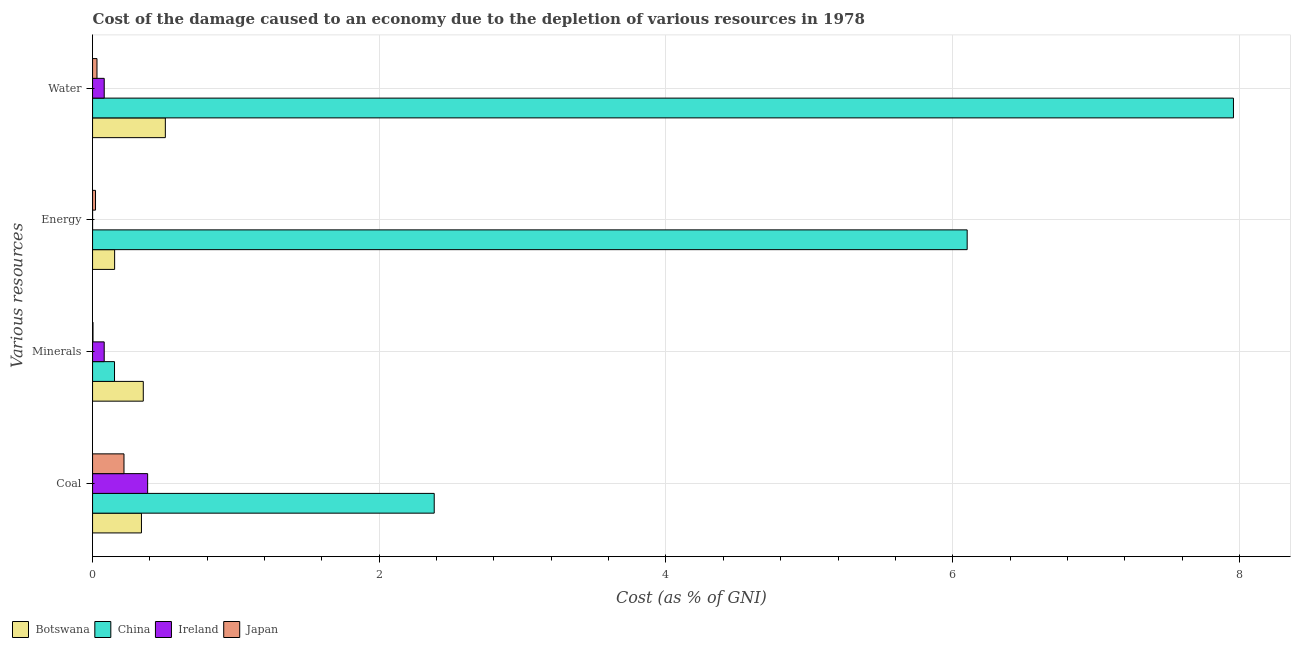How many groups of bars are there?
Your response must be concise. 4. Are the number of bars per tick equal to the number of legend labels?
Offer a terse response. Yes. Are the number of bars on each tick of the Y-axis equal?
Offer a very short reply. Yes. How many bars are there on the 4th tick from the top?
Provide a succinct answer. 4. How many bars are there on the 1st tick from the bottom?
Your answer should be very brief. 4. What is the label of the 1st group of bars from the top?
Ensure brevity in your answer.  Water. What is the cost of damage due to depletion of minerals in Ireland?
Provide a succinct answer. 0.08. Across all countries, what is the maximum cost of damage due to depletion of water?
Your answer should be very brief. 7.96. Across all countries, what is the minimum cost of damage due to depletion of minerals?
Make the answer very short. 0. In which country was the cost of damage due to depletion of coal maximum?
Your answer should be very brief. China. What is the total cost of damage due to depletion of minerals in the graph?
Provide a succinct answer. 0.59. What is the difference between the cost of damage due to depletion of water in Botswana and that in Japan?
Provide a short and direct response. 0.48. What is the difference between the cost of damage due to depletion of minerals in Ireland and the cost of damage due to depletion of energy in China?
Provide a succinct answer. -6.02. What is the average cost of damage due to depletion of energy per country?
Ensure brevity in your answer.  1.57. What is the difference between the cost of damage due to depletion of water and cost of damage due to depletion of energy in China?
Give a very brief answer. 1.86. What is the ratio of the cost of damage due to depletion of water in Ireland to that in China?
Keep it short and to the point. 0.01. Is the cost of damage due to depletion of minerals in Botswana less than that in China?
Offer a terse response. No. Is the difference between the cost of damage due to depletion of energy in China and Botswana greater than the difference between the cost of damage due to depletion of minerals in China and Botswana?
Ensure brevity in your answer.  Yes. What is the difference between the highest and the second highest cost of damage due to depletion of minerals?
Provide a succinct answer. 0.2. What is the difference between the highest and the lowest cost of damage due to depletion of energy?
Keep it short and to the point. 6.1. In how many countries, is the cost of damage due to depletion of energy greater than the average cost of damage due to depletion of energy taken over all countries?
Your answer should be compact. 1. What does the 4th bar from the top in Minerals represents?
Make the answer very short. Botswana. What does the 2nd bar from the bottom in Minerals represents?
Make the answer very short. China. Is it the case that in every country, the sum of the cost of damage due to depletion of coal and cost of damage due to depletion of minerals is greater than the cost of damage due to depletion of energy?
Offer a very short reply. No. How many bars are there?
Offer a terse response. 16. How many countries are there in the graph?
Your answer should be compact. 4. What is the difference between two consecutive major ticks on the X-axis?
Keep it short and to the point. 2. Does the graph contain grids?
Keep it short and to the point. Yes. How many legend labels are there?
Offer a very short reply. 4. What is the title of the graph?
Make the answer very short. Cost of the damage caused to an economy due to the depletion of various resources in 1978 . What is the label or title of the X-axis?
Provide a short and direct response. Cost (as % of GNI). What is the label or title of the Y-axis?
Your answer should be very brief. Various resources. What is the Cost (as % of GNI) in Botswana in Coal?
Make the answer very short. 0.34. What is the Cost (as % of GNI) of China in Coal?
Your answer should be very brief. 2.38. What is the Cost (as % of GNI) in Ireland in Coal?
Give a very brief answer. 0.38. What is the Cost (as % of GNI) in Japan in Coal?
Make the answer very short. 0.22. What is the Cost (as % of GNI) of Botswana in Minerals?
Provide a short and direct response. 0.35. What is the Cost (as % of GNI) in China in Minerals?
Keep it short and to the point. 0.15. What is the Cost (as % of GNI) of Ireland in Minerals?
Keep it short and to the point. 0.08. What is the Cost (as % of GNI) of Japan in Minerals?
Your answer should be compact. 0. What is the Cost (as % of GNI) in Botswana in Energy?
Your answer should be very brief. 0.15. What is the Cost (as % of GNI) of China in Energy?
Make the answer very short. 6.1. What is the Cost (as % of GNI) of Ireland in Energy?
Offer a terse response. 3.38604174226955e-5. What is the Cost (as % of GNI) of Japan in Energy?
Offer a terse response. 0.02. What is the Cost (as % of GNI) of Botswana in Water?
Offer a terse response. 0.51. What is the Cost (as % of GNI) of China in Water?
Your response must be concise. 7.96. What is the Cost (as % of GNI) in Ireland in Water?
Offer a terse response. 0.08. What is the Cost (as % of GNI) in Japan in Water?
Your response must be concise. 0.03. Across all Various resources, what is the maximum Cost (as % of GNI) of Botswana?
Provide a succinct answer. 0.51. Across all Various resources, what is the maximum Cost (as % of GNI) of China?
Your response must be concise. 7.96. Across all Various resources, what is the maximum Cost (as % of GNI) in Ireland?
Provide a succinct answer. 0.38. Across all Various resources, what is the maximum Cost (as % of GNI) of Japan?
Give a very brief answer. 0.22. Across all Various resources, what is the minimum Cost (as % of GNI) of Botswana?
Keep it short and to the point. 0.15. Across all Various resources, what is the minimum Cost (as % of GNI) of China?
Your answer should be very brief. 0.15. Across all Various resources, what is the minimum Cost (as % of GNI) of Ireland?
Provide a succinct answer. 3.38604174226955e-5. Across all Various resources, what is the minimum Cost (as % of GNI) of Japan?
Offer a very short reply. 0. What is the total Cost (as % of GNI) in Botswana in the graph?
Your response must be concise. 1.36. What is the total Cost (as % of GNI) of China in the graph?
Provide a succinct answer. 16.6. What is the total Cost (as % of GNI) of Ireland in the graph?
Keep it short and to the point. 0.55. What is the total Cost (as % of GNI) in Japan in the graph?
Give a very brief answer. 0.27. What is the difference between the Cost (as % of GNI) of Botswana in Coal and that in Minerals?
Your answer should be compact. -0.01. What is the difference between the Cost (as % of GNI) of China in Coal and that in Minerals?
Keep it short and to the point. 2.23. What is the difference between the Cost (as % of GNI) in Ireland in Coal and that in Minerals?
Provide a succinct answer. 0.3. What is the difference between the Cost (as % of GNI) of Japan in Coal and that in Minerals?
Offer a very short reply. 0.22. What is the difference between the Cost (as % of GNI) of Botswana in Coal and that in Energy?
Offer a terse response. 0.19. What is the difference between the Cost (as % of GNI) in China in Coal and that in Energy?
Offer a terse response. -3.72. What is the difference between the Cost (as % of GNI) in Ireland in Coal and that in Energy?
Offer a terse response. 0.38. What is the difference between the Cost (as % of GNI) of Japan in Coal and that in Energy?
Provide a succinct answer. 0.2. What is the difference between the Cost (as % of GNI) in China in Coal and that in Water?
Offer a very short reply. -5.58. What is the difference between the Cost (as % of GNI) in Ireland in Coal and that in Water?
Ensure brevity in your answer.  0.3. What is the difference between the Cost (as % of GNI) in Japan in Coal and that in Water?
Your answer should be very brief. 0.19. What is the difference between the Cost (as % of GNI) in Botswana in Minerals and that in Energy?
Offer a terse response. 0.2. What is the difference between the Cost (as % of GNI) of China in Minerals and that in Energy?
Provide a succinct answer. -5.95. What is the difference between the Cost (as % of GNI) in Ireland in Minerals and that in Energy?
Your response must be concise. 0.08. What is the difference between the Cost (as % of GNI) in Japan in Minerals and that in Energy?
Provide a succinct answer. -0.02. What is the difference between the Cost (as % of GNI) in Botswana in Minerals and that in Water?
Give a very brief answer. -0.15. What is the difference between the Cost (as % of GNI) of China in Minerals and that in Water?
Keep it short and to the point. -7.81. What is the difference between the Cost (as % of GNI) of Ireland in Minerals and that in Water?
Offer a terse response. -0. What is the difference between the Cost (as % of GNI) in Japan in Minerals and that in Water?
Offer a terse response. -0.03. What is the difference between the Cost (as % of GNI) of Botswana in Energy and that in Water?
Keep it short and to the point. -0.35. What is the difference between the Cost (as % of GNI) of China in Energy and that in Water?
Provide a short and direct response. -1.86. What is the difference between the Cost (as % of GNI) of Ireland in Energy and that in Water?
Ensure brevity in your answer.  -0.08. What is the difference between the Cost (as % of GNI) in Japan in Energy and that in Water?
Your response must be concise. -0.01. What is the difference between the Cost (as % of GNI) of Botswana in Coal and the Cost (as % of GNI) of China in Minerals?
Your answer should be very brief. 0.19. What is the difference between the Cost (as % of GNI) of Botswana in Coal and the Cost (as % of GNI) of Ireland in Minerals?
Your answer should be compact. 0.26. What is the difference between the Cost (as % of GNI) in Botswana in Coal and the Cost (as % of GNI) in Japan in Minerals?
Ensure brevity in your answer.  0.34. What is the difference between the Cost (as % of GNI) in China in Coal and the Cost (as % of GNI) in Ireland in Minerals?
Give a very brief answer. 2.3. What is the difference between the Cost (as % of GNI) in China in Coal and the Cost (as % of GNI) in Japan in Minerals?
Ensure brevity in your answer.  2.38. What is the difference between the Cost (as % of GNI) in Ireland in Coal and the Cost (as % of GNI) in Japan in Minerals?
Offer a very short reply. 0.38. What is the difference between the Cost (as % of GNI) of Botswana in Coal and the Cost (as % of GNI) of China in Energy?
Your answer should be very brief. -5.76. What is the difference between the Cost (as % of GNI) of Botswana in Coal and the Cost (as % of GNI) of Ireland in Energy?
Provide a succinct answer. 0.34. What is the difference between the Cost (as % of GNI) of Botswana in Coal and the Cost (as % of GNI) of Japan in Energy?
Your response must be concise. 0.32. What is the difference between the Cost (as % of GNI) of China in Coal and the Cost (as % of GNI) of Ireland in Energy?
Offer a terse response. 2.38. What is the difference between the Cost (as % of GNI) in China in Coal and the Cost (as % of GNI) in Japan in Energy?
Your answer should be very brief. 2.36. What is the difference between the Cost (as % of GNI) of Ireland in Coal and the Cost (as % of GNI) of Japan in Energy?
Keep it short and to the point. 0.36. What is the difference between the Cost (as % of GNI) in Botswana in Coal and the Cost (as % of GNI) in China in Water?
Provide a succinct answer. -7.62. What is the difference between the Cost (as % of GNI) of Botswana in Coal and the Cost (as % of GNI) of Ireland in Water?
Offer a terse response. 0.26. What is the difference between the Cost (as % of GNI) in Botswana in Coal and the Cost (as % of GNI) in Japan in Water?
Provide a short and direct response. 0.31. What is the difference between the Cost (as % of GNI) in China in Coal and the Cost (as % of GNI) in Ireland in Water?
Ensure brevity in your answer.  2.3. What is the difference between the Cost (as % of GNI) in China in Coal and the Cost (as % of GNI) in Japan in Water?
Ensure brevity in your answer.  2.35. What is the difference between the Cost (as % of GNI) of Ireland in Coal and the Cost (as % of GNI) of Japan in Water?
Provide a short and direct response. 0.35. What is the difference between the Cost (as % of GNI) of Botswana in Minerals and the Cost (as % of GNI) of China in Energy?
Provide a succinct answer. -5.75. What is the difference between the Cost (as % of GNI) of Botswana in Minerals and the Cost (as % of GNI) of Ireland in Energy?
Your answer should be very brief. 0.35. What is the difference between the Cost (as % of GNI) of Botswana in Minerals and the Cost (as % of GNI) of Japan in Energy?
Keep it short and to the point. 0.33. What is the difference between the Cost (as % of GNI) in China in Minerals and the Cost (as % of GNI) in Ireland in Energy?
Keep it short and to the point. 0.15. What is the difference between the Cost (as % of GNI) of China in Minerals and the Cost (as % of GNI) of Japan in Energy?
Keep it short and to the point. 0.13. What is the difference between the Cost (as % of GNI) of Ireland in Minerals and the Cost (as % of GNI) of Japan in Energy?
Ensure brevity in your answer.  0.06. What is the difference between the Cost (as % of GNI) of Botswana in Minerals and the Cost (as % of GNI) of China in Water?
Offer a very short reply. -7.6. What is the difference between the Cost (as % of GNI) in Botswana in Minerals and the Cost (as % of GNI) in Ireland in Water?
Offer a terse response. 0.27. What is the difference between the Cost (as % of GNI) in Botswana in Minerals and the Cost (as % of GNI) in Japan in Water?
Make the answer very short. 0.32. What is the difference between the Cost (as % of GNI) of China in Minerals and the Cost (as % of GNI) of Ireland in Water?
Your answer should be compact. 0.07. What is the difference between the Cost (as % of GNI) of China in Minerals and the Cost (as % of GNI) of Japan in Water?
Make the answer very short. 0.12. What is the difference between the Cost (as % of GNI) in Ireland in Minerals and the Cost (as % of GNI) in Japan in Water?
Give a very brief answer. 0.05. What is the difference between the Cost (as % of GNI) in Botswana in Energy and the Cost (as % of GNI) in China in Water?
Ensure brevity in your answer.  -7.8. What is the difference between the Cost (as % of GNI) in Botswana in Energy and the Cost (as % of GNI) in Ireland in Water?
Make the answer very short. 0.07. What is the difference between the Cost (as % of GNI) of Botswana in Energy and the Cost (as % of GNI) of Japan in Water?
Give a very brief answer. 0.12. What is the difference between the Cost (as % of GNI) of China in Energy and the Cost (as % of GNI) of Ireland in Water?
Make the answer very short. 6.02. What is the difference between the Cost (as % of GNI) of China in Energy and the Cost (as % of GNI) of Japan in Water?
Provide a short and direct response. 6.07. What is the difference between the Cost (as % of GNI) of Ireland in Energy and the Cost (as % of GNI) of Japan in Water?
Your answer should be very brief. -0.03. What is the average Cost (as % of GNI) in Botswana per Various resources?
Your answer should be very brief. 0.34. What is the average Cost (as % of GNI) in China per Various resources?
Ensure brevity in your answer.  4.15. What is the average Cost (as % of GNI) of Ireland per Various resources?
Your response must be concise. 0.14. What is the average Cost (as % of GNI) of Japan per Various resources?
Keep it short and to the point. 0.07. What is the difference between the Cost (as % of GNI) of Botswana and Cost (as % of GNI) of China in Coal?
Keep it short and to the point. -2.04. What is the difference between the Cost (as % of GNI) in Botswana and Cost (as % of GNI) in Ireland in Coal?
Keep it short and to the point. -0.04. What is the difference between the Cost (as % of GNI) of Botswana and Cost (as % of GNI) of Japan in Coal?
Offer a terse response. 0.12. What is the difference between the Cost (as % of GNI) of China and Cost (as % of GNI) of Ireland in Coal?
Your answer should be compact. 2. What is the difference between the Cost (as % of GNI) of China and Cost (as % of GNI) of Japan in Coal?
Your response must be concise. 2.16. What is the difference between the Cost (as % of GNI) of Ireland and Cost (as % of GNI) of Japan in Coal?
Your answer should be very brief. 0.17. What is the difference between the Cost (as % of GNI) of Botswana and Cost (as % of GNI) of China in Minerals?
Provide a succinct answer. 0.2. What is the difference between the Cost (as % of GNI) of Botswana and Cost (as % of GNI) of Ireland in Minerals?
Give a very brief answer. 0.27. What is the difference between the Cost (as % of GNI) in Botswana and Cost (as % of GNI) in Japan in Minerals?
Keep it short and to the point. 0.35. What is the difference between the Cost (as % of GNI) in China and Cost (as % of GNI) in Ireland in Minerals?
Offer a terse response. 0.07. What is the difference between the Cost (as % of GNI) in China and Cost (as % of GNI) in Japan in Minerals?
Your answer should be very brief. 0.15. What is the difference between the Cost (as % of GNI) of Ireland and Cost (as % of GNI) of Japan in Minerals?
Ensure brevity in your answer.  0.08. What is the difference between the Cost (as % of GNI) of Botswana and Cost (as % of GNI) of China in Energy?
Your response must be concise. -5.95. What is the difference between the Cost (as % of GNI) of Botswana and Cost (as % of GNI) of Ireland in Energy?
Your response must be concise. 0.15. What is the difference between the Cost (as % of GNI) in Botswana and Cost (as % of GNI) in Japan in Energy?
Provide a short and direct response. 0.13. What is the difference between the Cost (as % of GNI) of China and Cost (as % of GNI) of Ireland in Energy?
Your response must be concise. 6.1. What is the difference between the Cost (as % of GNI) of China and Cost (as % of GNI) of Japan in Energy?
Keep it short and to the point. 6.08. What is the difference between the Cost (as % of GNI) of Ireland and Cost (as % of GNI) of Japan in Energy?
Ensure brevity in your answer.  -0.02. What is the difference between the Cost (as % of GNI) of Botswana and Cost (as % of GNI) of China in Water?
Your response must be concise. -7.45. What is the difference between the Cost (as % of GNI) of Botswana and Cost (as % of GNI) of Ireland in Water?
Ensure brevity in your answer.  0.43. What is the difference between the Cost (as % of GNI) of Botswana and Cost (as % of GNI) of Japan in Water?
Your response must be concise. 0.48. What is the difference between the Cost (as % of GNI) in China and Cost (as % of GNI) in Ireland in Water?
Your answer should be compact. 7.88. What is the difference between the Cost (as % of GNI) in China and Cost (as % of GNI) in Japan in Water?
Offer a very short reply. 7.93. What is the difference between the Cost (as % of GNI) in Ireland and Cost (as % of GNI) in Japan in Water?
Provide a succinct answer. 0.05. What is the ratio of the Cost (as % of GNI) in Botswana in Coal to that in Minerals?
Give a very brief answer. 0.96. What is the ratio of the Cost (as % of GNI) of China in Coal to that in Minerals?
Give a very brief answer. 15.56. What is the ratio of the Cost (as % of GNI) in Ireland in Coal to that in Minerals?
Offer a terse response. 4.73. What is the ratio of the Cost (as % of GNI) in Japan in Coal to that in Minerals?
Your answer should be compact. 72.18. What is the ratio of the Cost (as % of GNI) of Botswana in Coal to that in Energy?
Offer a very short reply. 2.22. What is the ratio of the Cost (as % of GNI) of China in Coal to that in Energy?
Keep it short and to the point. 0.39. What is the ratio of the Cost (as % of GNI) of Ireland in Coal to that in Energy?
Provide a short and direct response. 1.13e+04. What is the ratio of the Cost (as % of GNI) of Japan in Coal to that in Energy?
Provide a short and direct response. 10.67. What is the ratio of the Cost (as % of GNI) of Botswana in Coal to that in Water?
Keep it short and to the point. 0.67. What is the ratio of the Cost (as % of GNI) in China in Coal to that in Water?
Keep it short and to the point. 0.3. What is the ratio of the Cost (as % of GNI) of Ireland in Coal to that in Water?
Offer a terse response. 4.73. What is the ratio of the Cost (as % of GNI) in Japan in Coal to that in Water?
Offer a terse response. 7.1. What is the ratio of the Cost (as % of GNI) in Botswana in Minerals to that in Energy?
Provide a succinct answer. 2.3. What is the ratio of the Cost (as % of GNI) in China in Minerals to that in Energy?
Make the answer very short. 0.03. What is the ratio of the Cost (as % of GNI) of Ireland in Minerals to that in Energy?
Your answer should be very brief. 2398.75. What is the ratio of the Cost (as % of GNI) in Japan in Minerals to that in Energy?
Make the answer very short. 0.15. What is the ratio of the Cost (as % of GNI) of Botswana in Minerals to that in Water?
Ensure brevity in your answer.  0.7. What is the ratio of the Cost (as % of GNI) of China in Minerals to that in Water?
Your answer should be very brief. 0.02. What is the ratio of the Cost (as % of GNI) of Ireland in Minerals to that in Water?
Provide a succinct answer. 1. What is the ratio of the Cost (as % of GNI) in Japan in Minerals to that in Water?
Offer a very short reply. 0.1. What is the ratio of the Cost (as % of GNI) of Botswana in Energy to that in Water?
Offer a terse response. 0.3. What is the ratio of the Cost (as % of GNI) of China in Energy to that in Water?
Provide a short and direct response. 0.77. What is the ratio of the Cost (as % of GNI) of Japan in Energy to that in Water?
Keep it short and to the point. 0.67. What is the difference between the highest and the second highest Cost (as % of GNI) of Botswana?
Offer a very short reply. 0.15. What is the difference between the highest and the second highest Cost (as % of GNI) in China?
Your answer should be compact. 1.86. What is the difference between the highest and the second highest Cost (as % of GNI) in Ireland?
Make the answer very short. 0.3. What is the difference between the highest and the second highest Cost (as % of GNI) of Japan?
Make the answer very short. 0.19. What is the difference between the highest and the lowest Cost (as % of GNI) of Botswana?
Offer a very short reply. 0.35. What is the difference between the highest and the lowest Cost (as % of GNI) of China?
Your response must be concise. 7.81. What is the difference between the highest and the lowest Cost (as % of GNI) in Ireland?
Your answer should be very brief. 0.38. What is the difference between the highest and the lowest Cost (as % of GNI) in Japan?
Give a very brief answer. 0.22. 